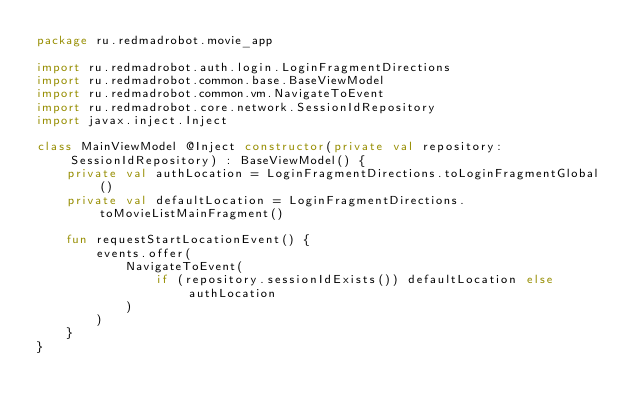<code> <loc_0><loc_0><loc_500><loc_500><_Kotlin_>package ru.redmadrobot.movie_app

import ru.redmadrobot.auth.login.LoginFragmentDirections
import ru.redmadrobot.common.base.BaseViewModel
import ru.redmadrobot.common.vm.NavigateToEvent
import ru.redmadrobot.core.network.SessionIdRepository
import javax.inject.Inject

class MainViewModel @Inject constructor(private val repository: SessionIdRepository) : BaseViewModel() {
    private val authLocation = LoginFragmentDirections.toLoginFragmentGlobal()
    private val defaultLocation = LoginFragmentDirections.toMovieListMainFragment()

    fun requestStartLocationEvent() {
        events.offer(
            NavigateToEvent(
                if (repository.sessionIdExists()) defaultLocation else authLocation
            )
        )
    }
}
</code> 